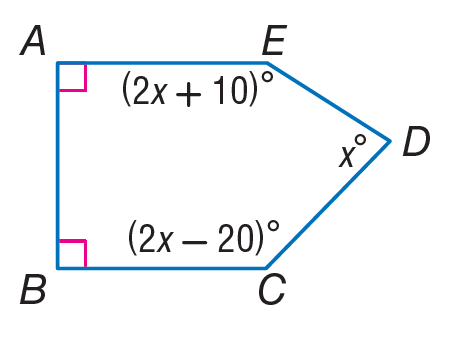Answer the mathemtical geometry problem and directly provide the correct option letter.
Question: Find m \angle D.
Choices: A: 36 B: 74 C: 78 D: 128 B 